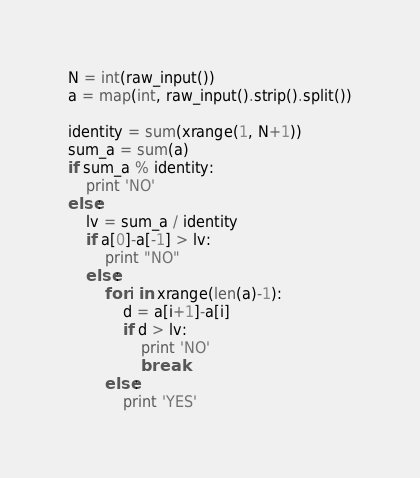<code> <loc_0><loc_0><loc_500><loc_500><_Python_>N = int(raw_input())
a = map(int, raw_input().strip().split())

identity = sum(xrange(1, N+1))
sum_a = sum(a)
if sum_a % identity:
    print 'NO'
else:
    lv = sum_a / identity
    if a[0]-a[-1] > lv:
        print "NO"
    else:
        for i in xrange(len(a)-1):
            d = a[i+1]-a[i]
            if d > lv:
                print 'NO'
                break
        else:
            print 'YES'</code> 